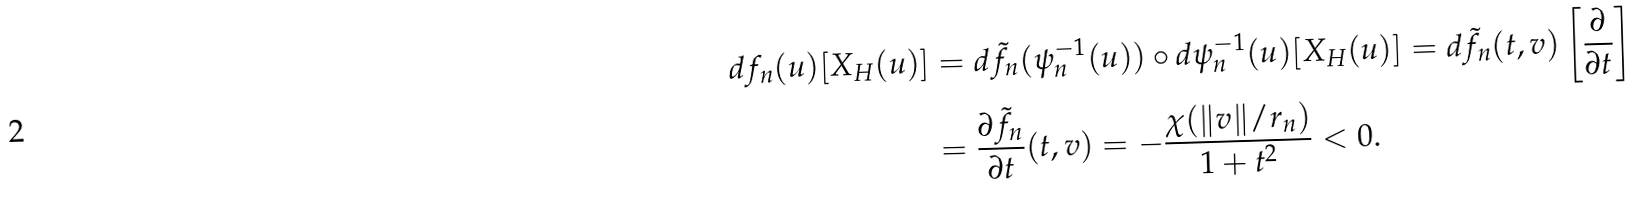<formula> <loc_0><loc_0><loc_500><loc_500>d f _ { n } ( u ) [ X _ { H } ( u ) ] & = d \tilde { f } _ { n } ( \psi _ { n } ^ { - 1 } ( u ) ) \circ d \psi _ { n } ^ { - 1 } ( u ) [ X _ { H } ( u ) ] = d \tilde { f } _ { n } ( t , v ) \left [ \frac { \partial } { \partial t } \right ] \\ & = \frac { \partial \tilde { f } _ { n } } { \partial t } ( t , v ) = - \frac { \chi ( \| v \| / r _ { n } ) } { 1 + t ^ { 2 } } < 0 .</formula> 